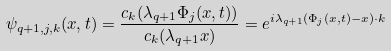Convert formula to latex. <formula><loc_0><loc_0><loc_500><loc_500>\psi _ { q + 1 , j , k } ( x , t ) = \frac { c _ { k } ( \lambda _ { q + 1 } \Phi _ { j } ( x , t ) ) } { c _ { k } ( \lambda _ { q + 1 } x ) } = e ^ { i \lambda _ { q + 1 } ( \Phi _ { j } ( x , t ) - x ) \cdot k }</formula> 